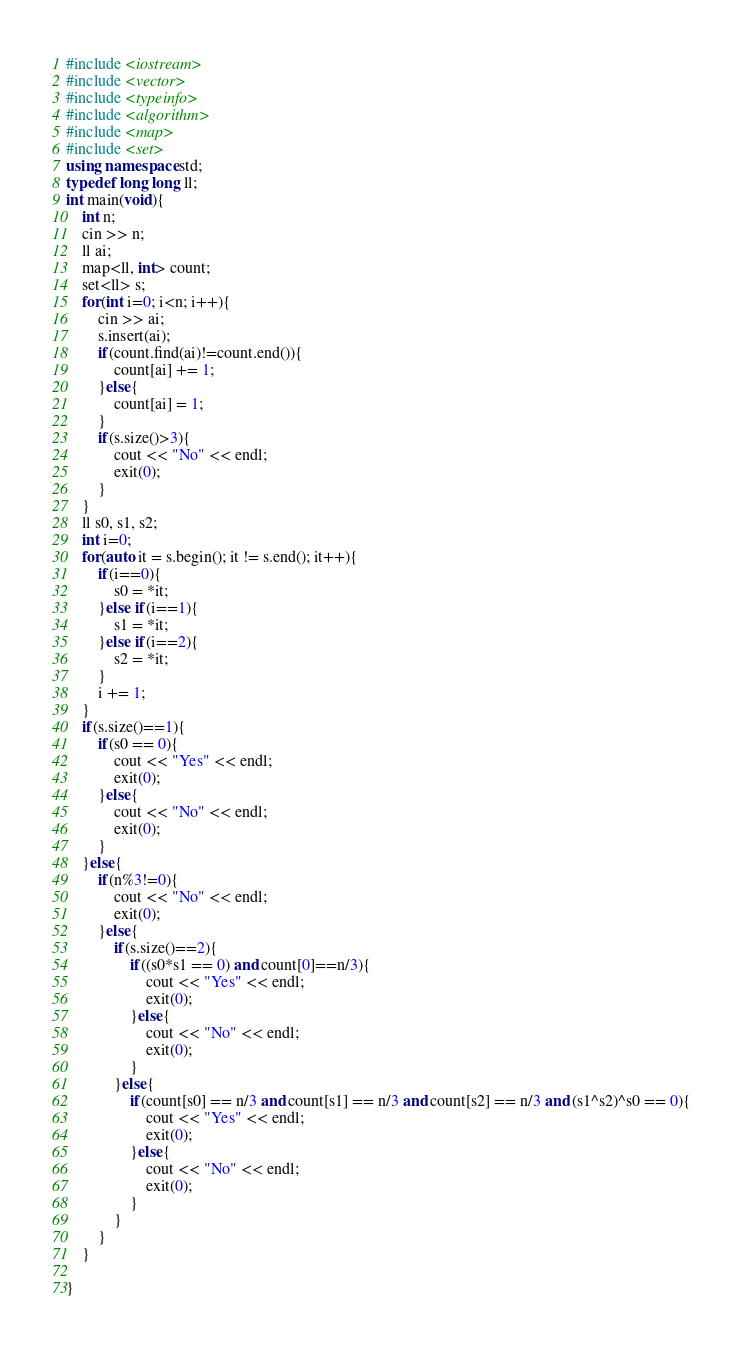Convert code to text. <code><loc_0><loc_0><loc_500><loc_500><_C++_>#include <iostream>
#include <vector>
#include <typeinfo>
#include <algorithm>
#include <map>
#include <set>
using namespace std;
typedef long long ll;
int main(void){
    int n;
    cin >> n;
    ll ai;
    map<ll, int> count;
    set<ll> s;
    for(int i=0; i<n; i++){
        cin >> ai;
        s.insert(ai);
        if(count.find(ai)!=count.end()){
            count[ai] += 1;
        }else{
            count[ai] = 1;
        }
        if(s.size()>3){
            cout << "No" << endl;
            exit(0);
        }
    }
    ll s0, s1, s2;
    int i=0;
    for(auto it = s.begin(); it != s.end(); it++){
        if(i==0){
            s0 = *it;
        }else if(i==1){
            s1 = *it;
        }else if(i==2){
            s2 = *it;
        }
        i += 1;
    }
    if(s.size()==1){
        if(s0 == 0){
            cout << "Yes" << endl;
            exit(0);
        }else{
            cout << "No" << endl;
            exit(0);
        }
    }else{
        if(n%3!=0){
            cout << "No" << endl;
            exit(0);
        }else{
            if(s.size()==2){
                if((s0*s1 == 0) and count[0]==n/3){
                    cout << "Yes" << endl;
                    exit(0);
                }else{
                    cout << "No" << endl;
                    exit(0);
                }
            }else{
                if(count[s0] == n/3 and count[s1] == n/3 and count[s2] == n/3 and (s1^s2)^s0 == 0){
                    cout << "Yes" << endl;
                    exit(0);
                }else{
                    cout << "No" << endl;
                    exit(0);
                }
            }
        }
    }

}</code> 